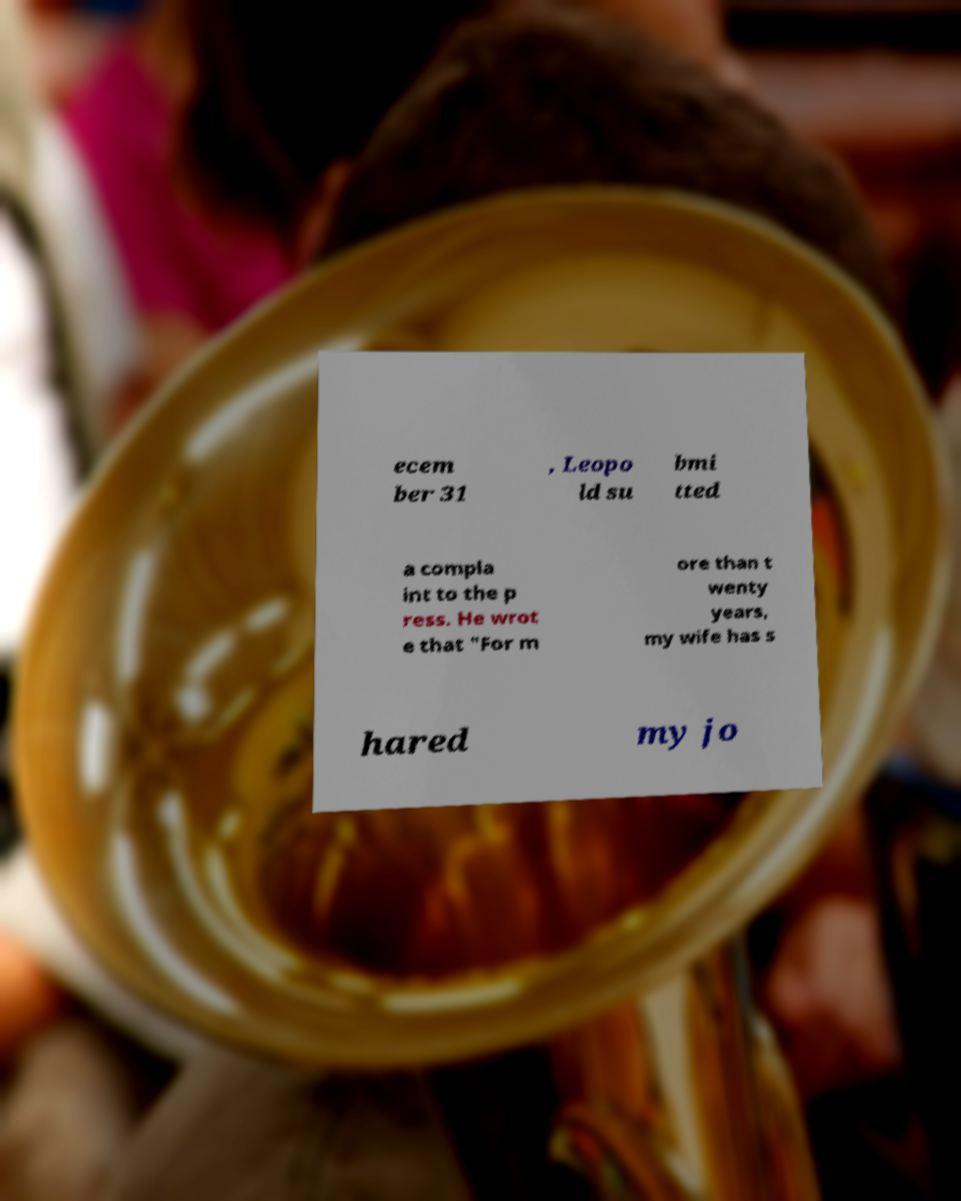Please read and relay the text visible in this image. What does it say? ecem ber 31 , Leopo ld su bmi tted a compla int to the p ress. He wrot e that "For m ore than t wenty years, my wife has s hared my jo 